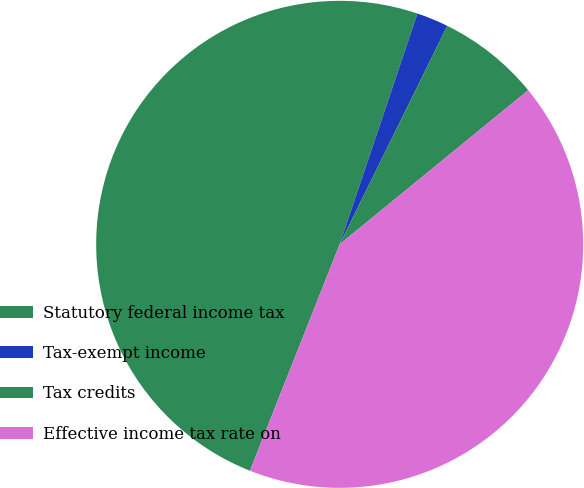Convert chart to OTSL. <chart><loc_0><loc_0><loc_500><loc_500><pie_chart><fcel>Statutory federal income tax<fcel>Tax-exempt income<fcel>Tax credits<fcel>Effective income tax rate on<nl><fcel>49.17%<fcel>2.11%<fcel>6.81%<fcel>41.91%<nl></chart> 